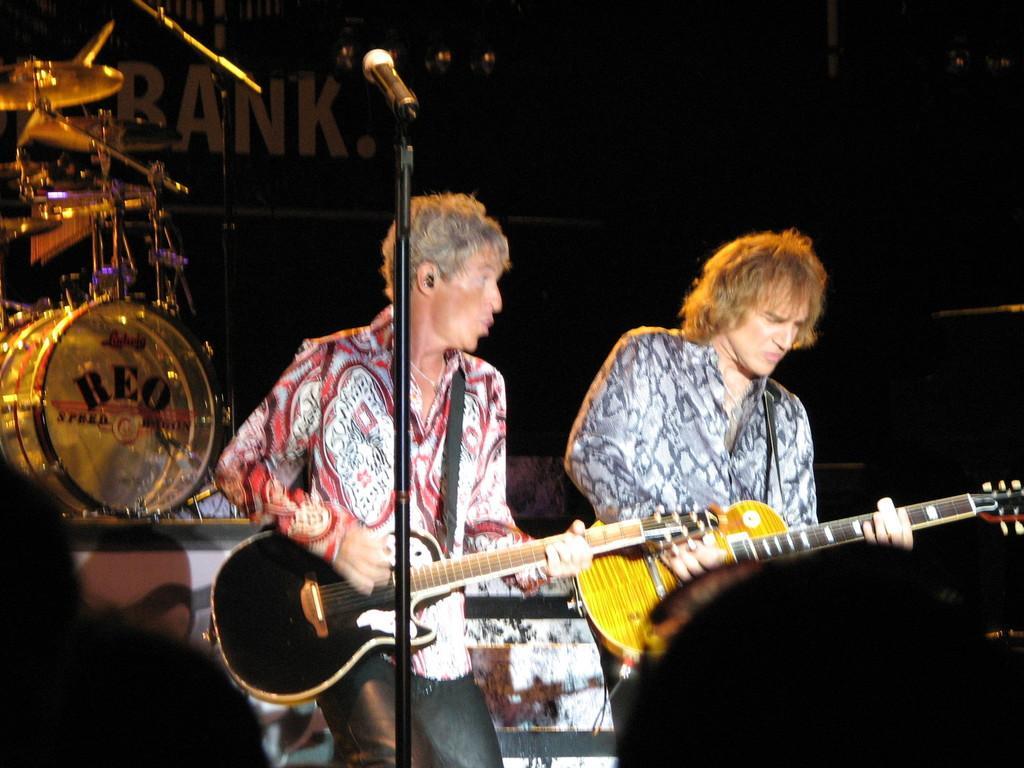Please provide a concise description of this image. Here we can see couple of men playing guitars having microphones in front of them and behind them we can see drums present 